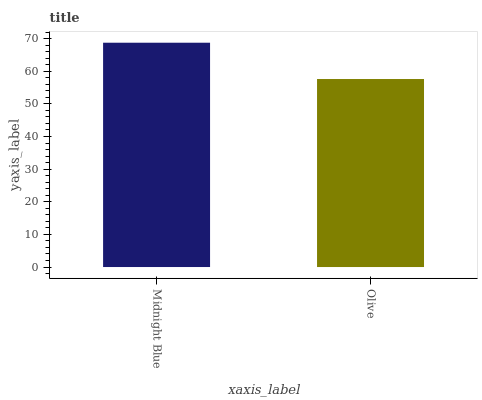Is Olive the minimum?
Answer yes or no. Yes. Is Midnight Blue the maximum?
Answer yes or no. Yes. Is Olive the maximum?
Answer yes or no. No. Is Midnight Blue greater than Olive?
Answer yes or no. Yes. Is Olive less than Midnight Blue?
Answer yes or no. Yes. Is Olive greater than Midnight Blue?
Answer yes or no. No. Is Midnight Blue less than Olive?
Answer yes or no. No. Is Midnight Blue the high median?
Answer yes or no. Yes. Is Olive the low median?
Answer yes or no. Yes. Is Olive the high median?
Answer yes or no. No. Is Midnight Blue the low median?
Answer yes or no. No. 